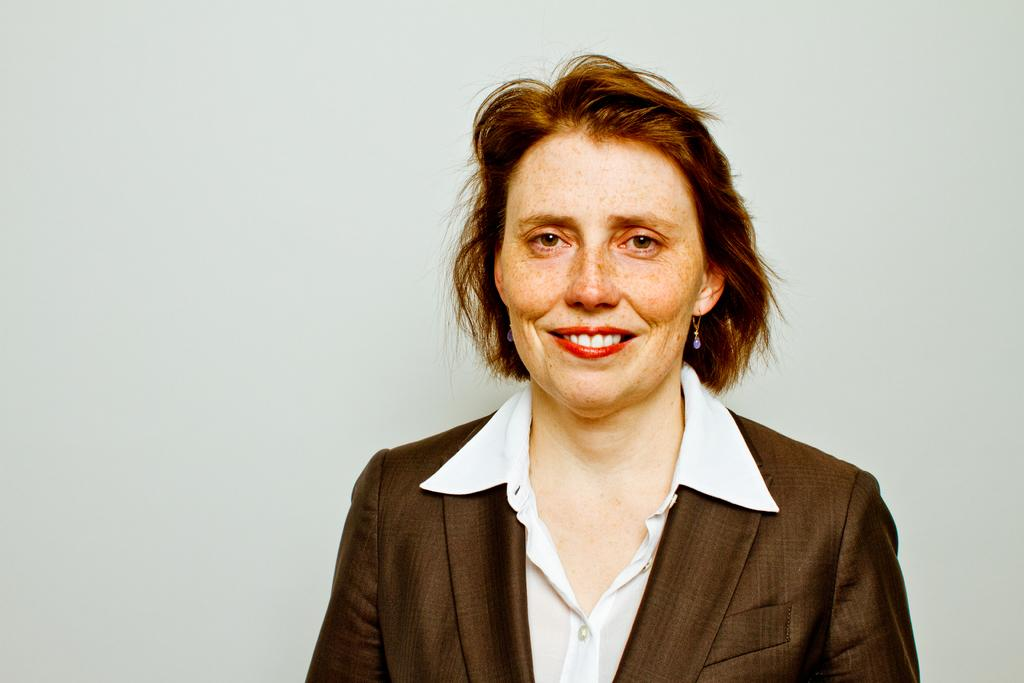Who is present in the image? There is a woman in the image. What is the woman wearing on her upper body? The woman is wearing a shirt and a blazer. What type of accessory is the woman wearing? The woman is wearing earrings. What is the woman's facial expression? The woman is smiling. What can be seen in the background of the image? There is a wall in the background of the image. What type of destruction can be seen happening to the quartz in the image? There is no destruction or quartz present in the image; it features a woman wearing a shirt, blazer, and earrings, with a wall in the background. 